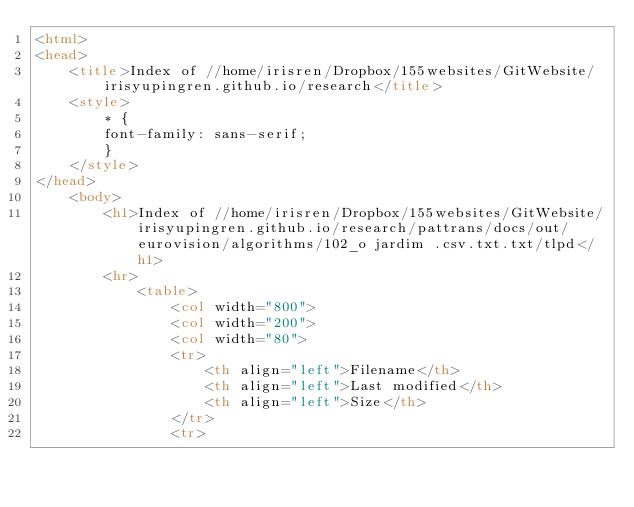<code> <loc_0><loc_0><loc_500><loc_500><_HTML_><html>
<head>
    <title>Index of //home/irisren/Dropbox/155websites/GitWebsite/irisyupingren.github.io/research</title>
    <style>
        * {
        font-family: sans-serif;
        }
    </style>
</head>
    <body>
        <h1>Index of //home/irisren/Dropbox/155websites/GitWebsite/irisyupingren.github.io/research/pattrans/docs/out/eurovision/algorithms/102_o jardim .csv.txt.txt/tlpd</h1>
        <hr>
            <table>
                <col width="800">
                <col width="200">
                <col width="80">
                <tr>
                    <th align="left">Filename</th>
                    <th align="left">Last modified</th>
                    <th align="left">Size</th>
                </tr>
                <tr></code> 